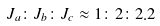<formula> <loc_0><loc_0><loc_500><loc_500>J _ { a } \colon J _ { b } \colon J _ { c } \approx 1 \colon 2 \colon 2 . 2</formula> 